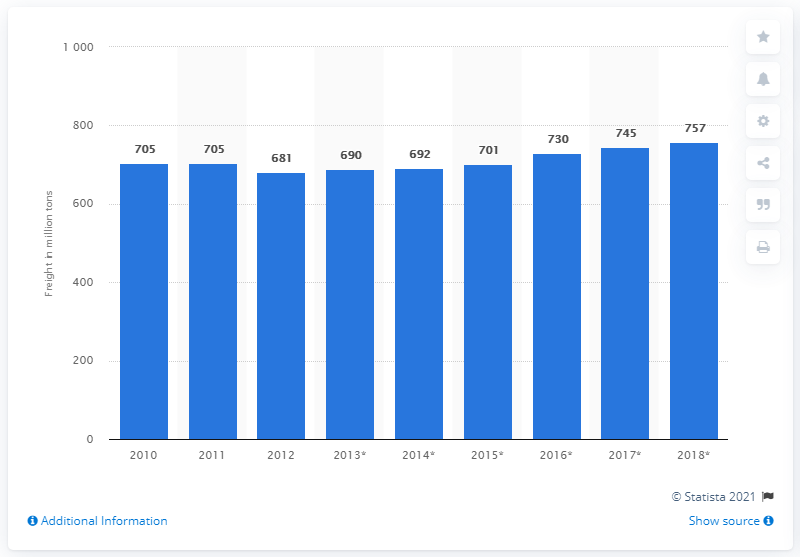Give some essential details in this illustration. In 2018, approximately 757 tons of freight were transported by road in the Netherlands. 